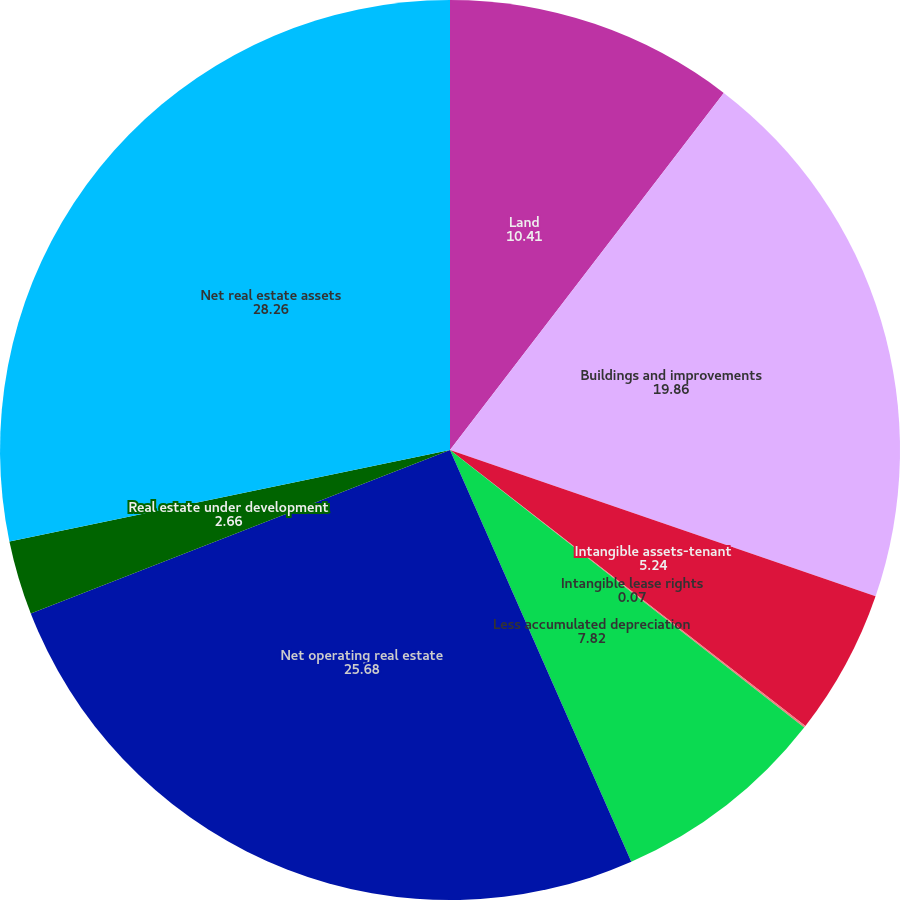Convert chart to OTSL. <chart><loc_0><loc_0><loc_500><loc_500><pie_chart><fcel>Land<fcel>Buildings and improvements<fcel>Intangible assets-tenant<fcel>Intangible lease rights<fcel>Less accumulated depreciation<fcel>Net operating real estate<fcel>Real estate under development<fcel>Net real estate assets<nl><fcel>10.41%<fcel>19.86%<fcel>5.24%<fcel>0.07%<fcel>7.82%<fcel>25.68%<fcel>2.66%<fcel>28.26%<nl></chart> 